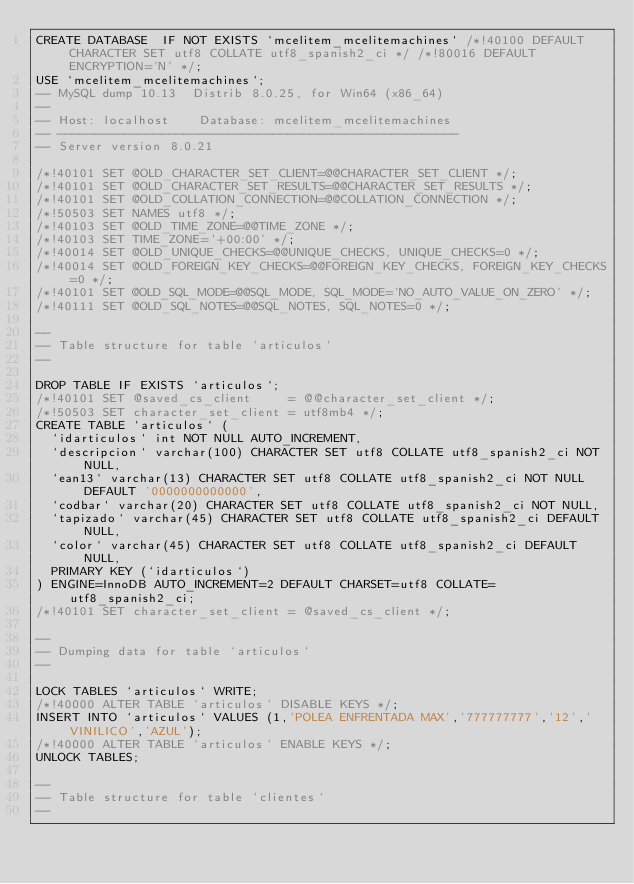<code> <loc_0><loc_0><loc_500><loc_500><_SQL_>CREATE DATABASE  IF NOT EXISTS `mcelitem_mcelitemachines` /*!40100 DEFAULT CHARACTER SET utf8 COLLATE utf8_spanish2_ci */ /*!80016 DEFAULT ENCRYPTION='N' */;
USE `mcelitem_mcelitemachines`;
-- MySQL dump 10.13  Distrib 8.0.25, for Win64 (x86_64)
--
-- Host: localhost    Database: mcelitem_mcelitemachines
-- ------------------------------------------------------
-- Server version	8.0.21

/*!40101 SET @OLD_CHARACTER_SET_CLIENT=@@CHARACTER_SET_CLIENT */;
/*!40101 SET @OLD_CHARACTER_SET_RESULTS=@@CHARACTER_SET_RESULTS */;
/*!40101 SET @OLD_COLLATION_CONNECTION=@@COLLATION_CONNECTION */;
/*!50503 SET NAMES utf8 */;
/*!40103 SET @OLD_TIME_ZONE=@@TIME_ZONE */;
/*!40103 SET TIME_ZONE='+00:00' */;
/*!40014 SET @OLD_UNIQUE_CHECKS=@@UNIQUE_CHECKS, UNIQUE_CHECKS=0 */;
/*!40014 SET @OLD_FOREIGN_KEY_CHECKS=@@FOREIGN_KEY_CHECKS, FOREIGN_KEY_CHECKS=0 */;
/*!40101 SET @OLD_SQL_MODE=@@SQL_MODE, SQL_MODE='NO_AUTO_VALUE_ON_ZERO' */;
/*!40111 SET @OLD_SQL_NOTES=@@SQL_NOTES, SQL_NOTES=0 */;

--
-- Table structure for table `articulos`
--

DROP TABLE IF EXISTS `articulos`;
/*!40101 SET @saved_cs_client     = @@character_set_client */;
/*!50503 SET character_set_client = utf8mb4 */;
CREATE TABLE `articulos` (
  `idarticulos` int NOT NULL AUTO_INCREMENT,
  `descripcion` varchar(100) CHARACTER SET utf8 COLLATE utf8_spanish2_ci NOT NULL,
  `ean13` varchar(13) CHARACTER SET utf8 COLLATE utf8_spanish2_ci NOT NULL DEFAULT '0000000000000',
  `codbar` varchar(20) CHARACTER SET utf8 COLLATE utf8_spanish2_ci NOT NULL,
  `tapizado` varchar(45) CHARACTER SET utf8 COLLATE utf8_spanish2_ci DEFAULT NULL,
  `color` varchar(45) CHARACTER SET utf8 COLLATE utf8_spanish2_ci DEFAULT NULL,
  PRIMARY KEY (`idarticulos`)
) ENGINE=InnoDB AUTO_INCREMENT=2 DEFAULT CHARSET=utf8 COLLATE=utf8_spanish2_ci;
/*!40101 SET character_set_client = @saved_cs_client */;

--
-- Dumping data for table `articulos`
--

LOCK TABLES `articulos` WRITE;
/*!40000 ALTER TABLE `articulos` DISABLE KEYS */;
INSERT INTO `articulos` VALUES (1,'POLEA ENFRENTADA MAX','777777777','12','VINILICO','AZUL');
/*!40000 ALTER TABLE `articulos` ENABLE KEYS */;
UNLOCK TABLES;

--
-- Table structure for table `clientes`
--
</code> 